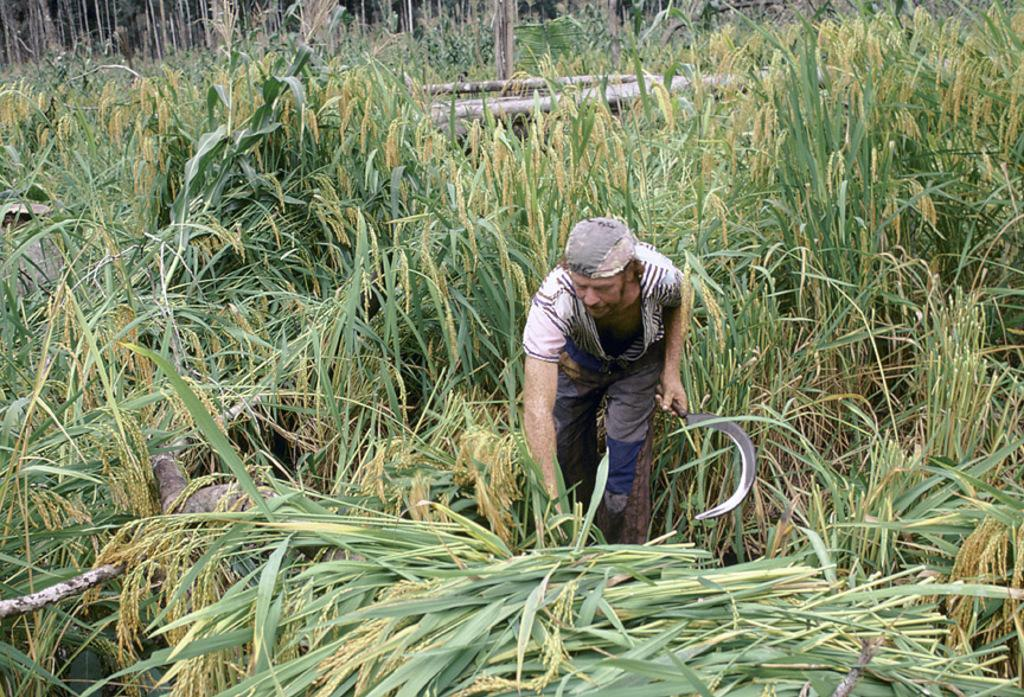What is the main subject of the image? There is a person standing in the image. Where is the person located in the image? The person is in the center of the image. What is the person standing on? The person is standing in plants. What is the person holding in the image? The person is holding a sickle. What can be seen in the background of the image? There are crops visible in the background of the image. What color is the stocking on the person's left foot in the image? There is no mention of a stocking or any footwear in the provided facts, so we cannot determine the color of a stocking on the person's left foot. 